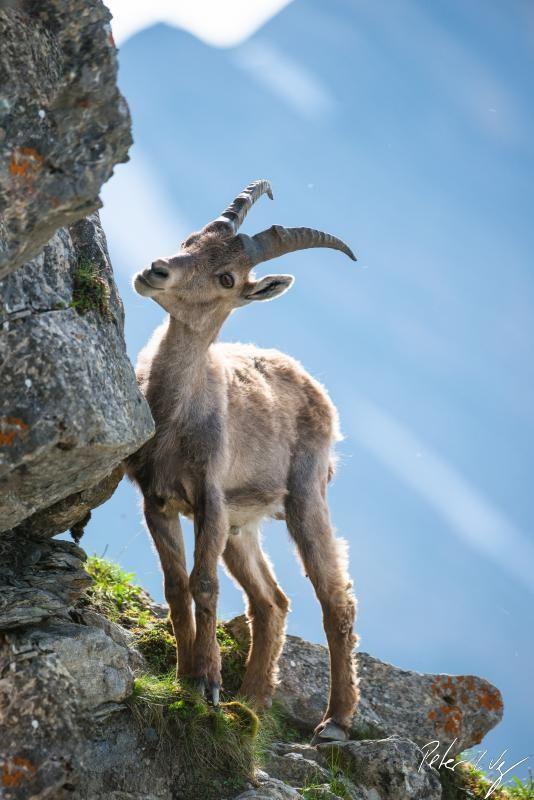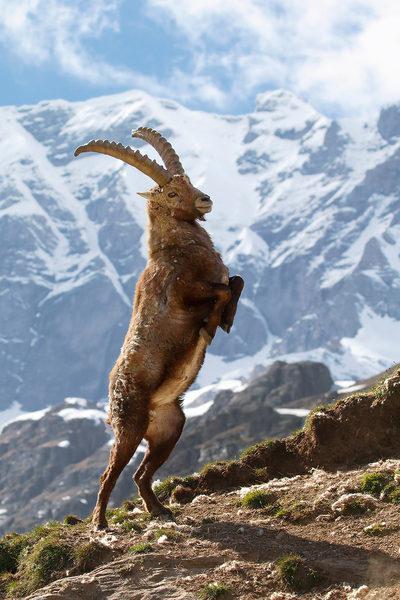The first image is the image on the left, the second image is the image on the right. For the images shown, is this caption "There is a single animal standing in a rocky area in the image on the left." true? Answer yes or no. Yes. The first image is the image on the left, the second image is the image on the right. For the images shown, is this caption "An image shows a ram with its head in profile, in a stark scene with no trees or green vegetation." true? Answer yes or no. No. 